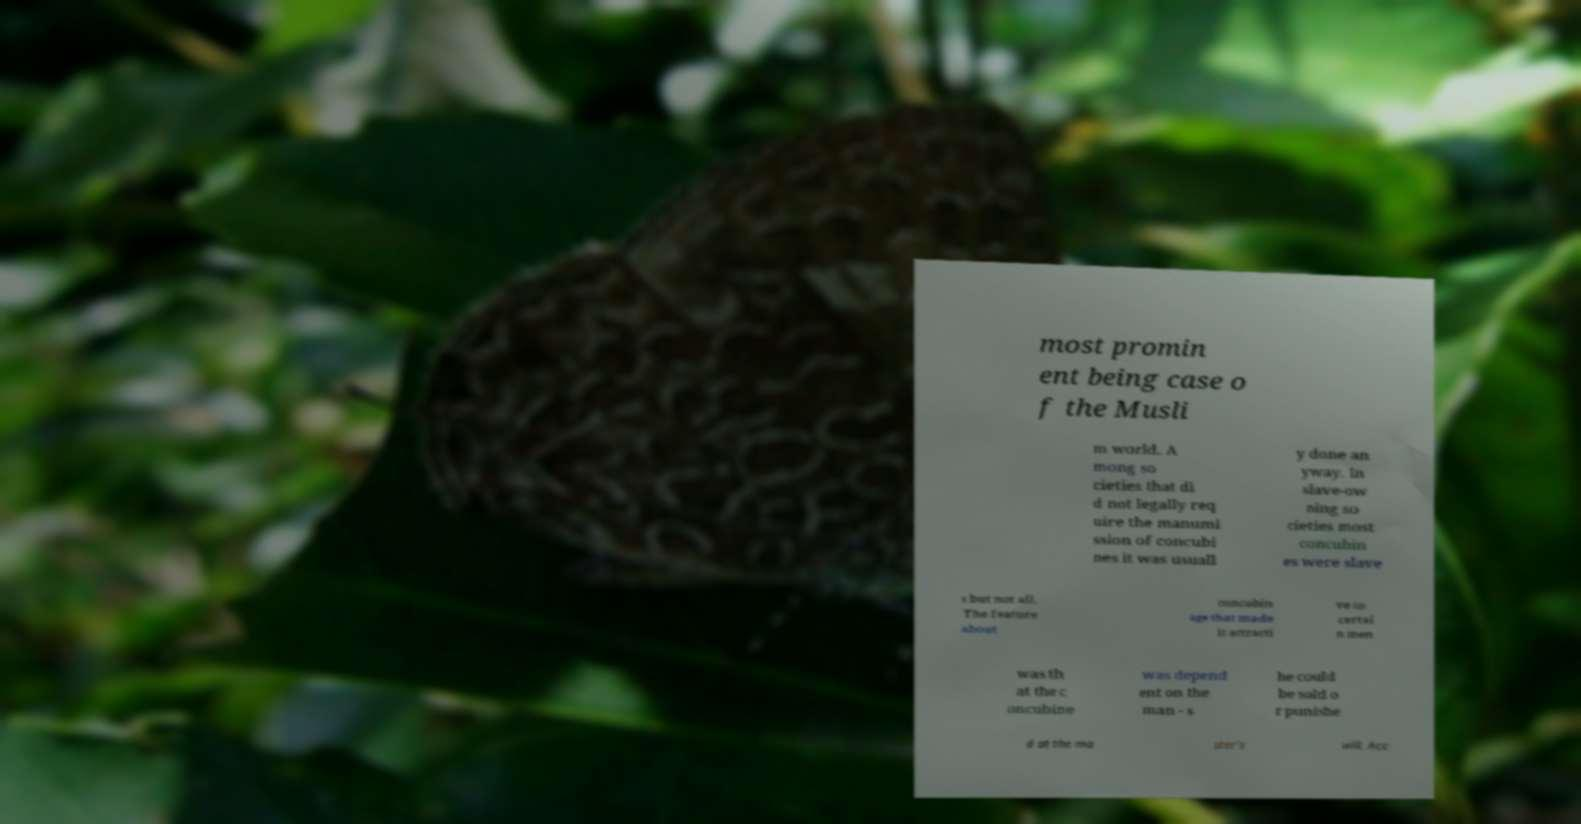I need the written content from this picture converted into text. Can you do that? most promin ent being case o f the Musli m world. A mong so cieties that di d not legally req uire the manumi ssion of concubi nes it was usuall y done an yway. In slave-ow ning so cieties most concubin es were slave s but not all. The feature about concubin age that made it attracti ve to certai n men was th at the c oncubine was depend ent on the man - s he could be sold o r punishe d at the ma ster's will. Acc 